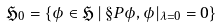<formula> <loc_0><loc_0><loc_500><loc_500>\mathfrak { H } _ { 0 } = \{ \phi \in \mathfrak { H } \, | \, \S P { \phi , \phi } | _ { \lambda = 0 } = 0 \}</formula> 